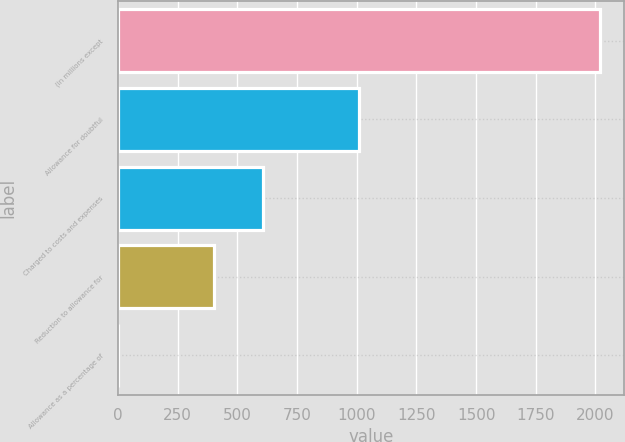Convert chart to OTSL. <chart><loc_0><loc_0><loc_500><loc_500><bar_chart><fcel>(in millions except<fcel>Allowance for doubtful<fcel>Charged to costs and expenses<fcel>Reduction to allowance for<fcel>Allowance as a percentage of<nl><fcel>2018<fcel>1009.05<fcel>605.47<fcel>403.68<fcel>0.1<nl></chart> 